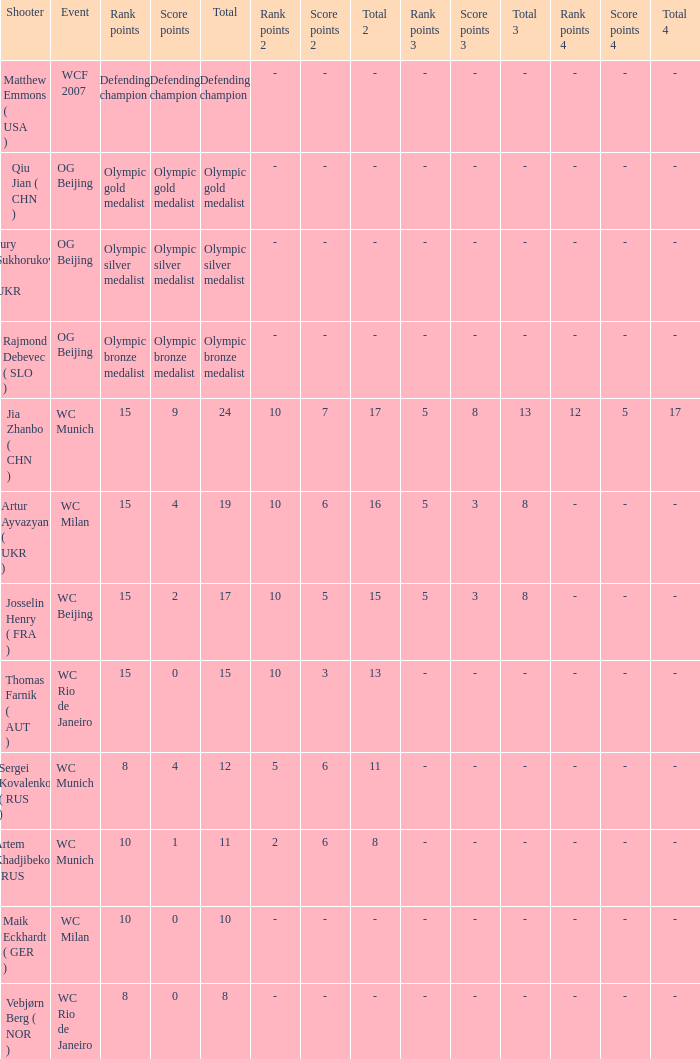Would you be able to parse every entry in this table? {'header': ['Shooter', 'Event', 'Rank points', 'Score points', 'Total', 'Rank points 2', 'Score points 2', 'Total 2', 'Rank points 3', 'Score points 3', 'Total 3', 'Rank points 4', 'Score points 4', 'Total 4'], 'rows': [['Matthew Emmons ( USA )', 'WCF 2007', 'Defending champion', 'Defending champion', 'Defending champion', '-', '-', '-', '-', '-', '-', '-', '-', '-'], ['Qiu Jian ( CHN )', 'OG Beijing', 'Olympic gold medalist', 'Olympic gold medalist', 'Olympic gold medalist', '-', '-', '-', '-', '-', '-', '-', '-', '-'], ['Jury Sukhorukov ( UKR )', 'OG Beijing', 'Olympic silver medalist', 'Olympic silver medalist', 'Olympic silver medalist', '-', '-', '-', '-', '-', '-', '-', '-', '-'], ['Rajmond Debevec ( SLO )', 'OG Beijing', 'Olympic bronze medalist', 'Olympic bronze medalist', 'Olympic bronze medalist', '-', '-', '-', '-', '-', '-', '-', '-', '-'], ['Jia Zhanbo ( CHN )', 'WC Munich', '15', '9', '24', '10', '7', '17', '5', '8', '13', '12', '5', '17'], ['Artur Ayvazyan ( UKR )', 'WC Milan', '15', '4', '19', '10', '6', '16', '5', '3', '8', '-', '-', '-'], ['Josselin Henry ( FRA )', 'WC Beijing', '15', '2', '17', '10', '5', '15', '5', '3', '8', '-', '-', '-'], ['Thomas Farnik ( AUT )', 'WC Rio de Janeiro', '15', '0', '15', '10', '3', '13', '-', '-', '-', '-', '-', '-'], ['Sergei Kovalenko ( RUS )', 'WC Munich', '8', '4', '12', '5', '6', '11', '-', '-', '-', '-', '-', '-'], ['Artem Khadjibekov ( RUS )', 'WC Munich', '10', '1', '11', '2', '6', '8', '-', '-', '-', '-', '-', '-'], ['Maik Eckhardt ( GER )', 'WC Milan', '10', '0', '10', '-', '-', '-', '-', '-', '-', '-', '-', '-'], ['Vebjørn Berg ( NOR )', 'WC Rio de Janeiro', '8', '0', '8', '-', '-', '-', '-', '-', '-', '-', '-', '-']]} Who was the shooter for the WC Beijing event? Josselin Henry ( FRA ). 